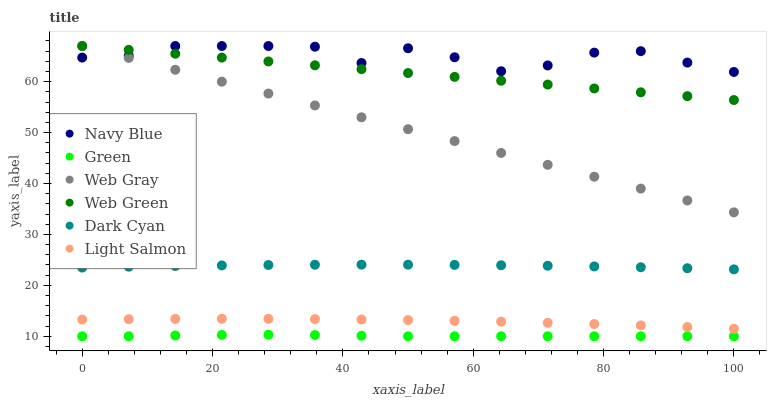Does Green have the minimum area under the curve?
Answer yes or no. Yes. Does Navy Blue have the maximum area under the curve?
Answer yes or no. Yes. Does Web Gray have the minimum area under the curve?
Answer yes or no. No. Does Web Gray have the maximum area under the curve?
Answer yes or no. No. Is Web Gray the smoothest?
Answer yes or no. Yes. Is Navy Blue the roughest?
Answer yes or no. Yes. Is Navy Blue the smoothest?
Answer yes or no. No. Is Web Gray the roughest?
Answer yes or no. No. Does Green have the lowest value?
Answer yes or no. Yes. Does Web Gray have the lowest value?
Answer yes or no. No. Does Web Green have the highest value?
Answer yes or no. Yes. Does Green have the highest value?
Answer yes or no. No. Is Light Salmon less than Dark Cyan?
Answer yes or no. Yes. Is Light Salmon greater than Green?
Answer yes or no. Yes. Does Navy Blue intersect Web Green?
Answer yes or no. Yes. Is Navy Blue less than Web Green?
Answer yes or no. No. Is Navy Blue greater than Web Green?
Answer yes or no. No. Does Light Salmon intersect Dark Cyan?
Answer yes or no. No. 